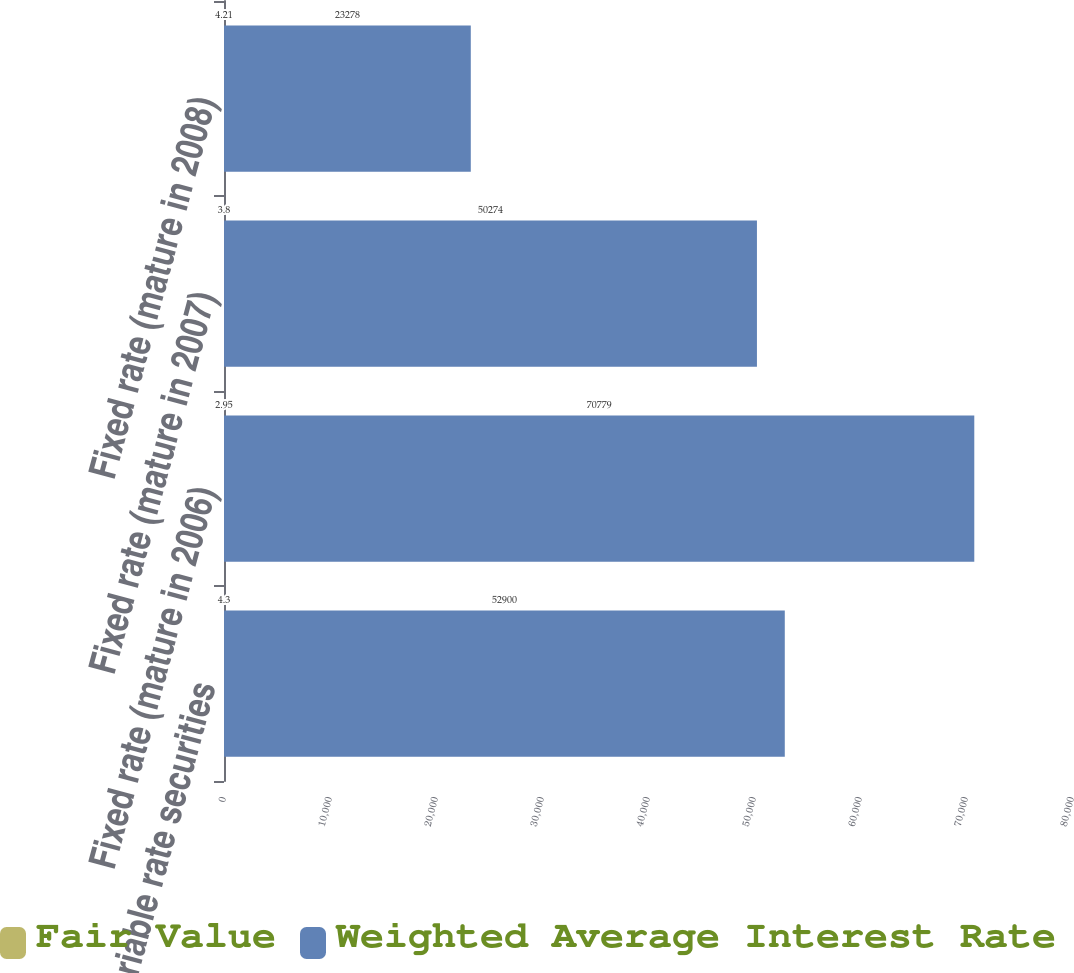Convert chart. <chart><loc_0><loc_0><loc_500><loc_500><stacked_bar_chart><ecel><fcel>Variable rate securities<fcel>Fixed rate (mature in 2006)<fcel>Fixed rate (mature in 2007)<fcel>Fixed rate (mature in 2008)<nl><fcel>Fair Value<fcel>4.3<fcel>2.95<fcel>3.8<fcel>4.21<nl><fcel>Weighted Average Interest Rate<fcel>52900<fcel>70779<fcel>50274<fcel>23278<nl></chart> 